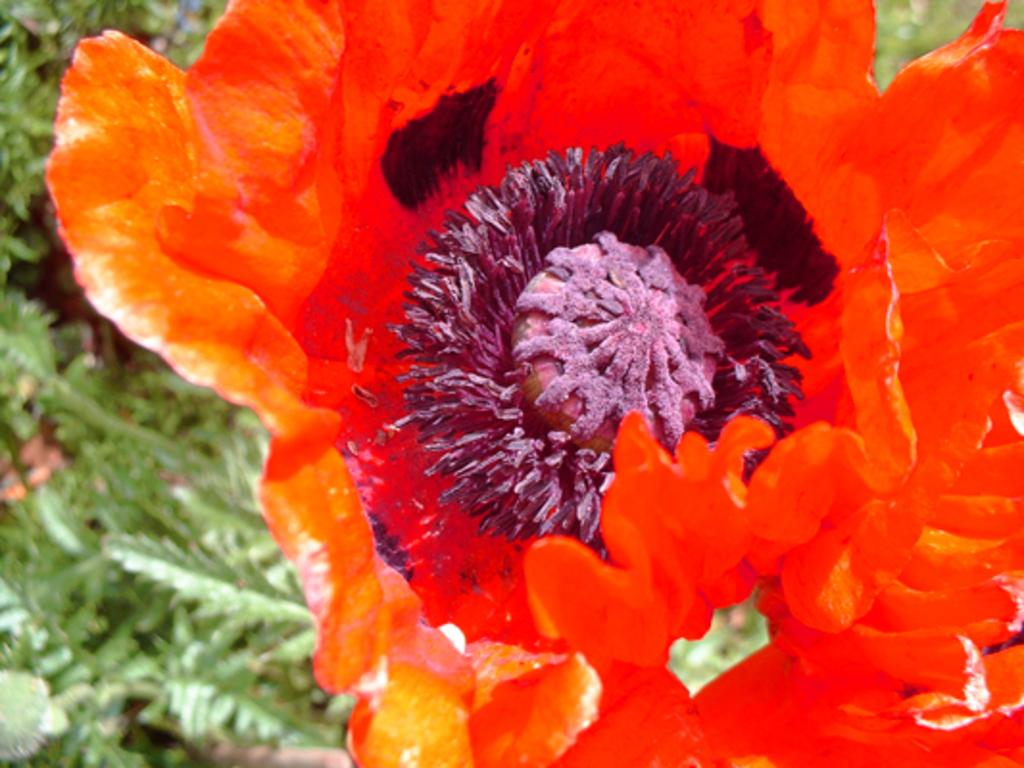What is the main subject of the picture? The main subject of the picture is a flower. Can you describe the colors of the flower? The flower has purple and orange colors. What else can be seen in the background of the picture? There are plants visible in the background of the picture. What type of rifle can be seen leaning against the flower in the image? There is no rifle present in the image; it features a flower with purple and orange colors and plants in the background. How does the flower help to stop the rainstorm in the image? The flower does not have the ability to stop a rainstorm, as it is a plant and not an object with such capabilities. 